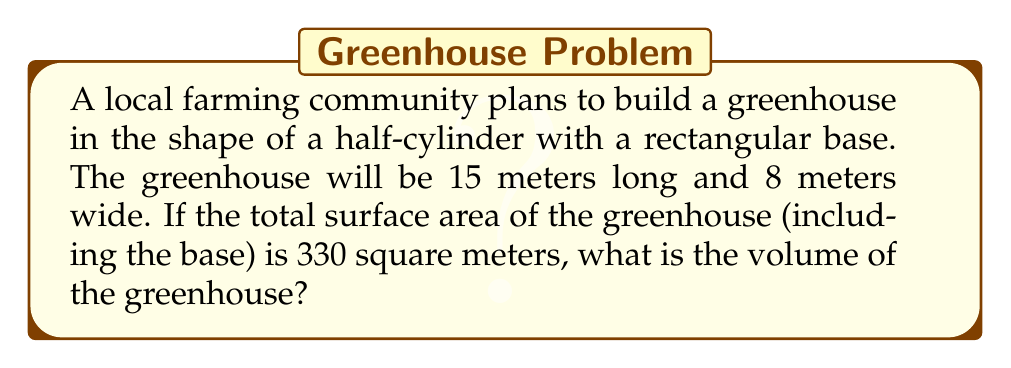Provide a solution to this math problem. Let's approach this step-by-step:

1) First, let's define our variables:
   $l$ = length = 15 m
   $w$ = width = 8 m
   $h$ = height (radius of the cylinder)

2) The surface area of a half-cylinder greenhouse consists of:
   - Rectangular base: $A_b = l \cdot w$
   - Rectangular front and back: $A_f = w \cdot h$
   - Curved roof: $A_r = \pi \cdot r \cdot l$

3) Total surface area:
   $A_{total} = A_b + 2A_f + A_r$
   $330 = (l \cdot w) + 2(w \cdot h) + (\pi \cdot h \cdot l)$

4) Substitute known values:
   $330 = (15 \cdot 8) + 2(8 \cdot h) + (\pi \cdot h \cdot 15)$
   $330 = 120 + 16h + 15\pi h$

5) Solve for $h$:
   $210 = 16h + 15\pi h$
   $210 = h(16 + 15\pi)$
   $h = \frac{210}{16 + 15\pi} \approx 3.78$ m

6) Now that we know $h$, we can calculate the volume:
   $V = \frac{1}{2} \cdot \pi \cdot r^2 \cdot l$
   $V = \frac{1}{2} \cdot \pi \cdot h^2 \cdot l$
   $V = \frac{1}{2} \cdot \pi \cdot 3.78^2 \cdot 15$
   $V \approx 336.9$ m³
Answer: $336.9$ m³ 